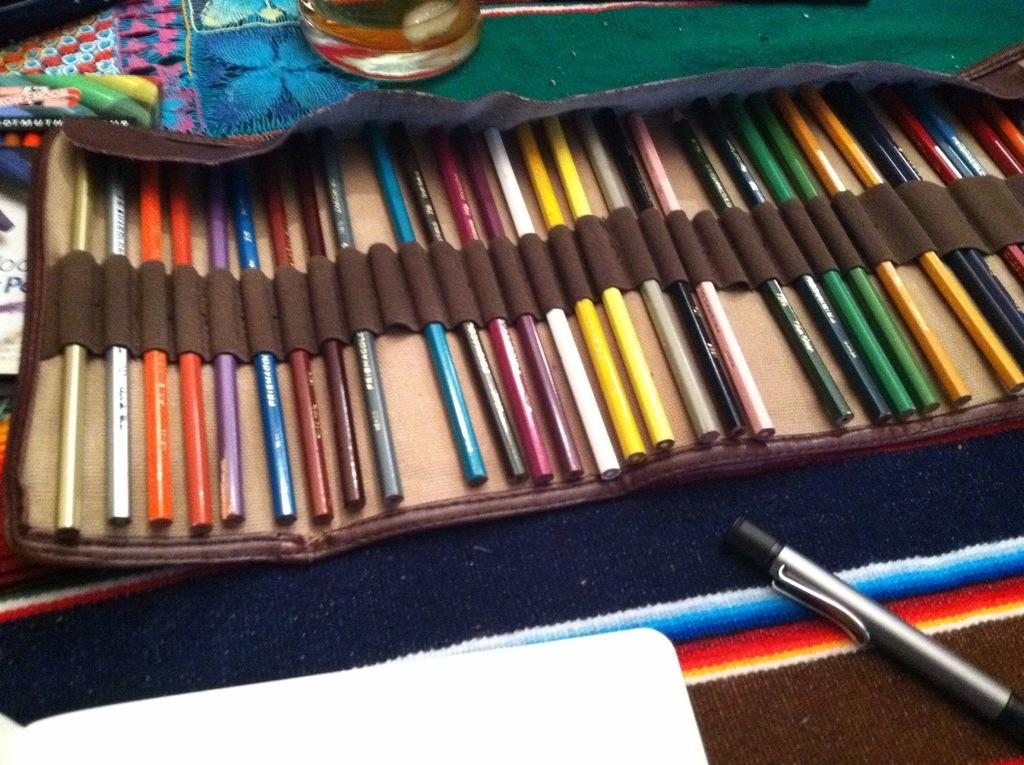What type of stationery items are present in the image? There is a bunch of colored pencils and a pen in the image. How are the colored pencils stored in the image? The colored pencils are placed in a pouch. What other items can be seen in the image? There is a cloth, a box, and a glass in the image. What type of coach is present in the image? There is no coach present in the image; it features stationery items and other objects. What type of glue is used to attach the colored pencils to the cloth in the image? There is no glue or attachment of colored pencils to the cloth in the image; the colored pencils are placed in a pouch. 